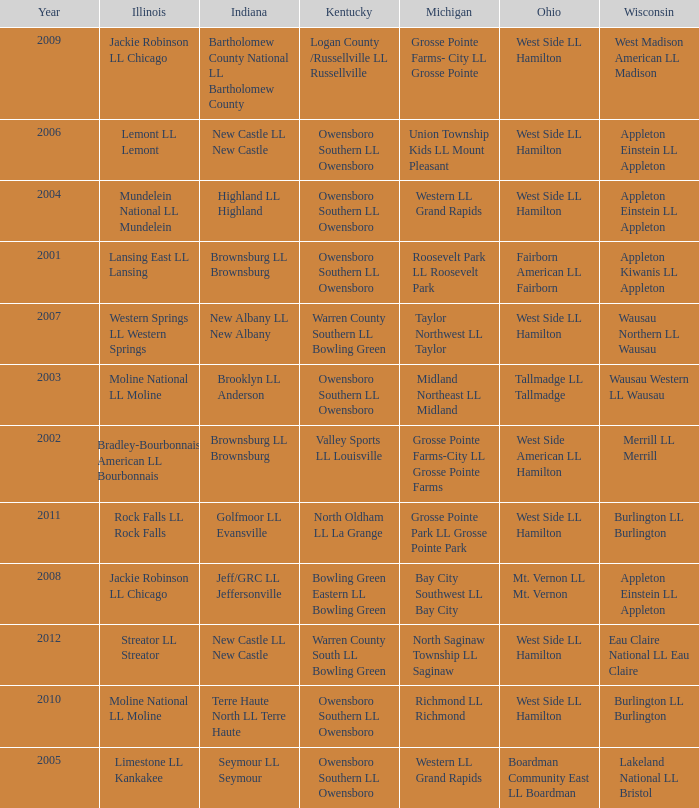What was the little league team from Ohio when the little league team from Kentucky was Warren County South LL Bowling Green? West Side LL Hamilton. 